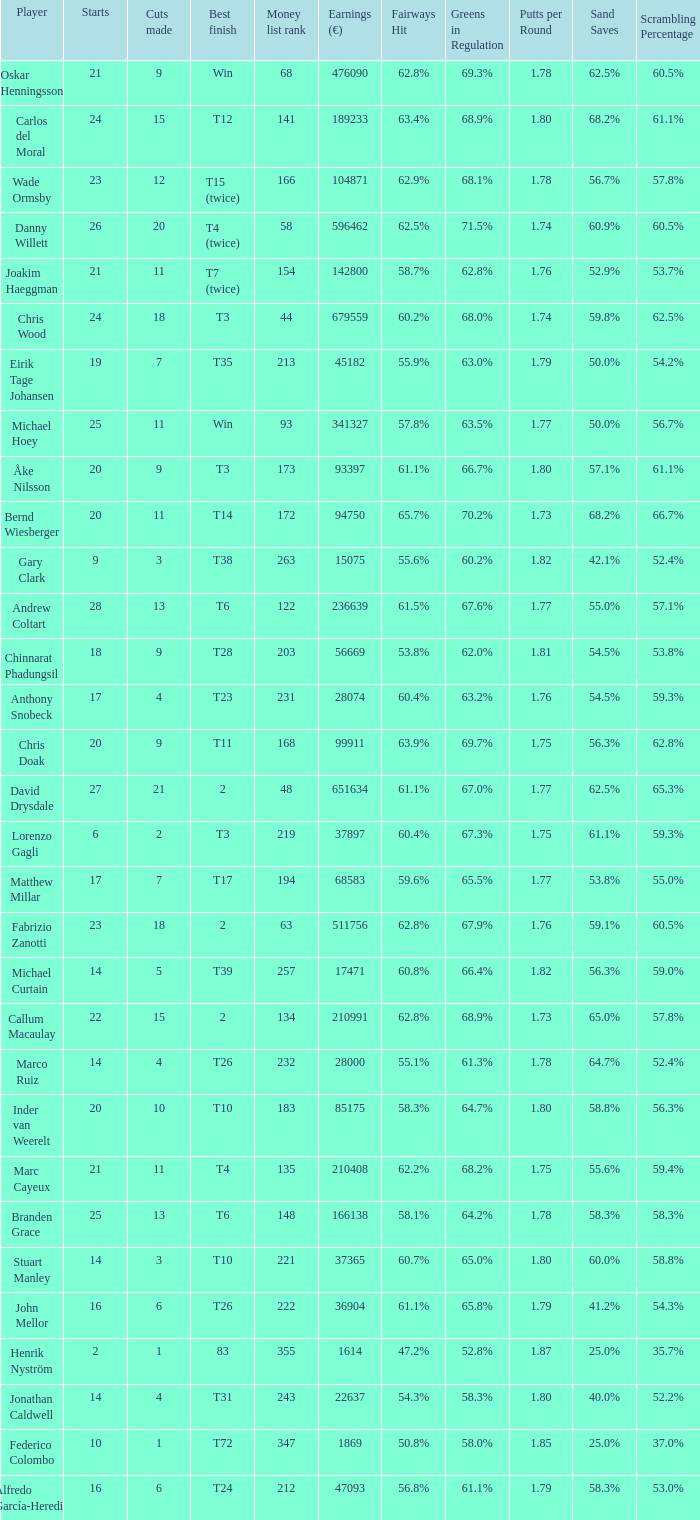How many cuts did Gary Clark make? 3.0. 